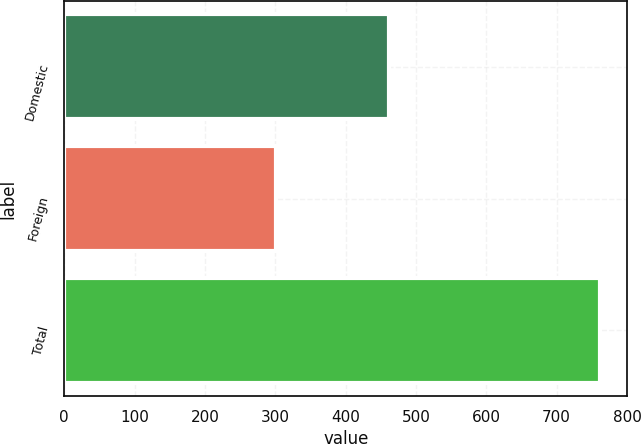<chart> <loc_0><loc_0><loc_500><loc_500><bar_chart><fcel>Domestic<fcel>Foreign<fcel>Total<nl><fcel>461<fcel>301.2<fcel>762.2<nl></chart> 